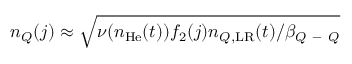Convert formula to latex. <formula><loc_0><loc_0><loc_500><loc_500>n _ { Q } ( j ) \approx \sqrt { \nu ( n _ { H e } ( t ) ) f _ { 2 } ( j ) n _ { Q , L R } ( t ) / \beta _ { Q - Q } }</formula> 